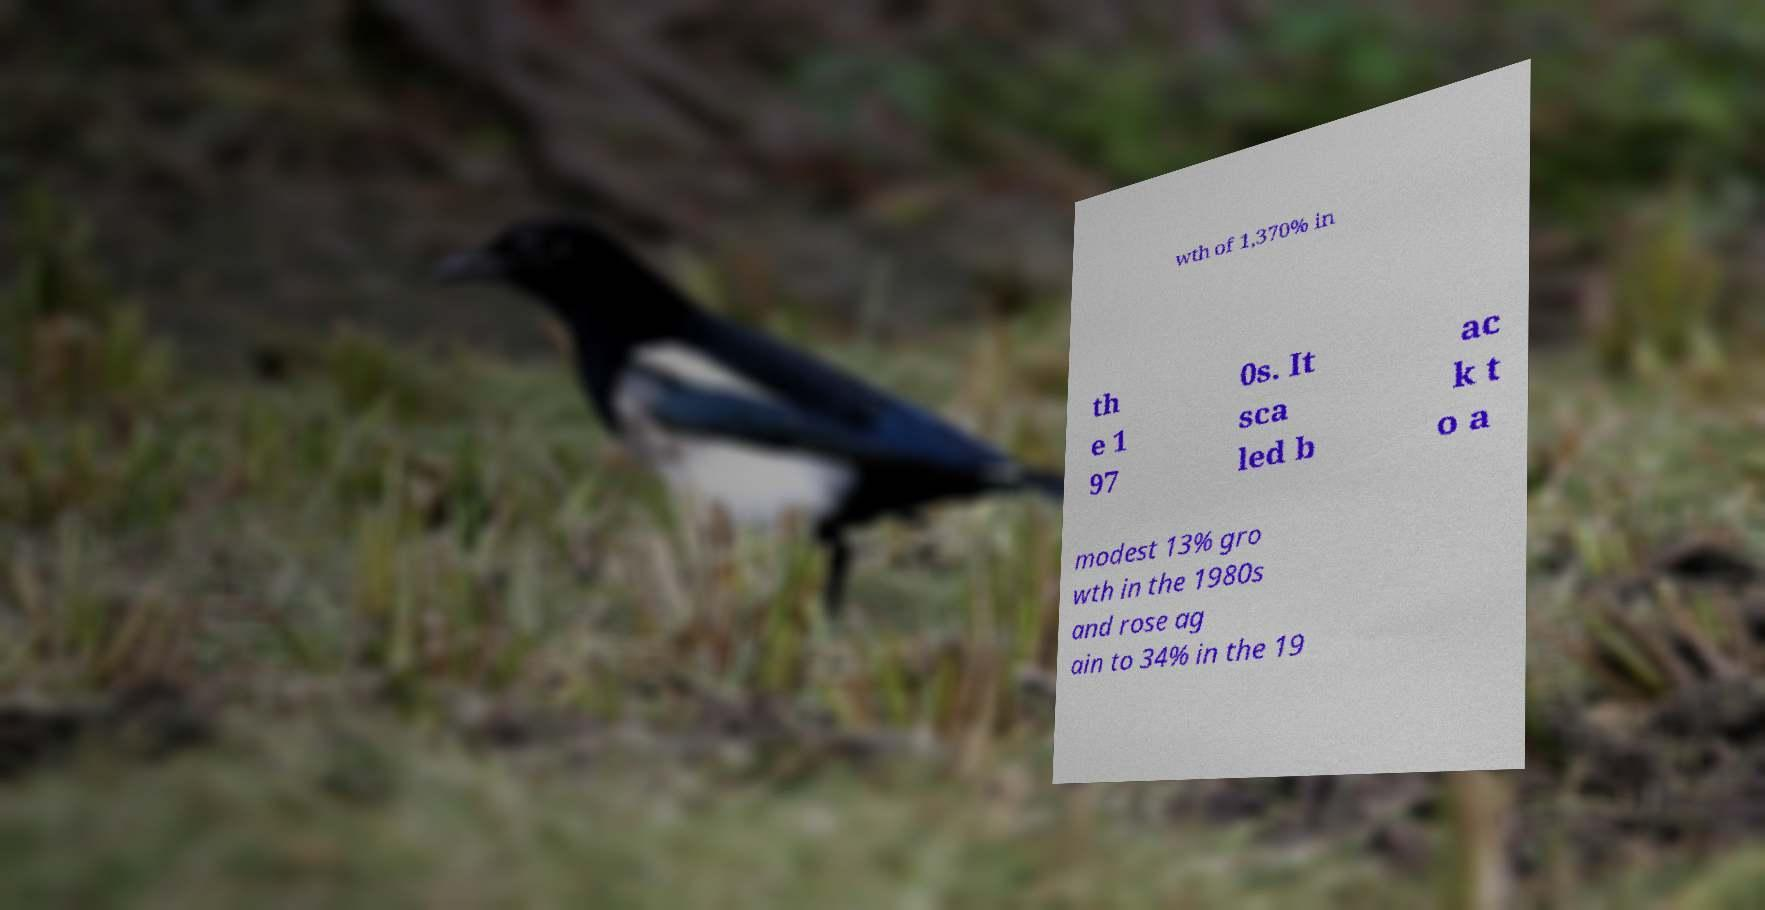Can you accurately transcribe the text from the provided image for me? wth of 1,370% in th e 1 97 0s. It sca led b ac k t o a modest 13% gro wth in the 1980s and rose ag ain to 34% in the 19 